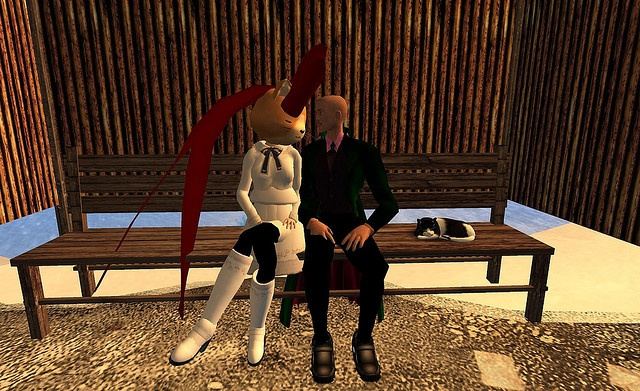Describe the objects in this image and their specific colors. I can see bench in black, maroon, and khaki tones, people in black, maroon, and brown tones, cat in black, gray, maroon, and khaki tones, and tie in black tones in this image. 